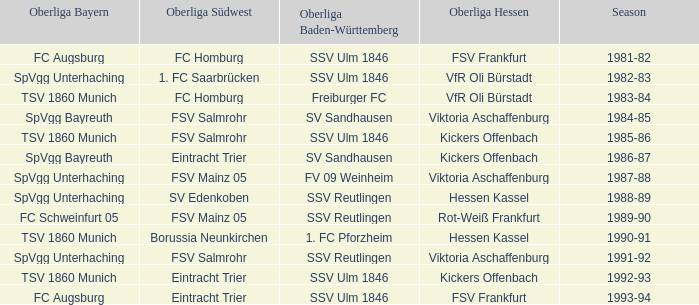Which oberliga südwes has an oberliga baden-württemberg of sv sandhausen in 1984-85? FSV Salmrohr. 